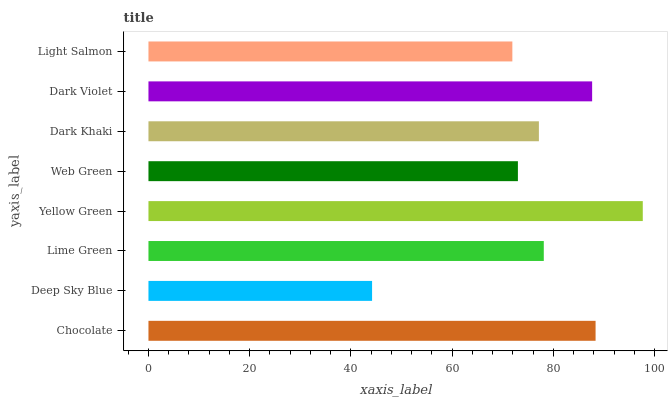Is Deep Sky Blue the minimum?
Answer yes or no. Yes. Is Yellow Green the maximum?
Answer yes or no. Yes. Is Lime Green the minimum?
Answer yes or no. No. Is Lime Green the maximum?
Answer yes or no. No. Is Lime Green greater than Deep Sky Blue?
Answer yes or no. Yes. Is Deep Sky Blue less than Lime Green?
Answer yes or no. Yes. Is Deep Sky Blue greater than Lime Green?
Answer yes or no. No. Is Lime Green less than Deep Sky Blue?
Answer yes or no. No. Is Lime Green the high median?
Answer yes or no. Yes. Is Dark Khaki the low median?
Answer yes or no. Yes. Is Dark Violet the high median?
Answer yes or no. No. Is Yellow Green the low median?
Answer yes or no. No. 